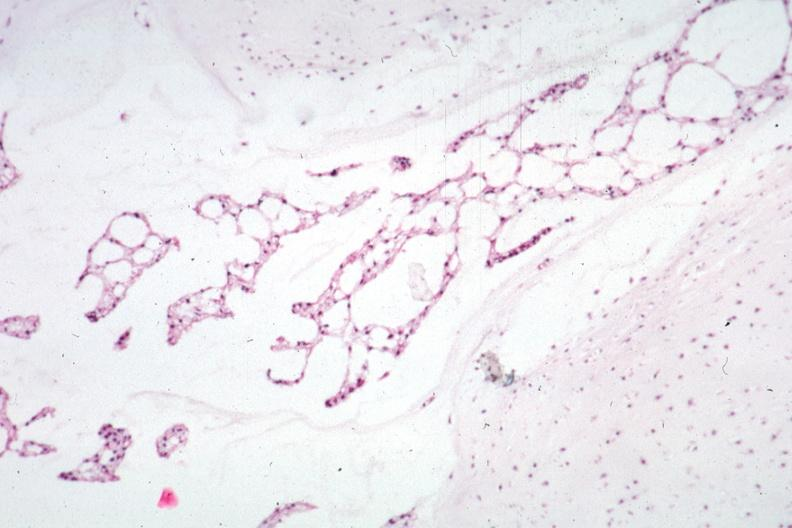what is present?
Answer the question using a single word or phrase. Notochord 